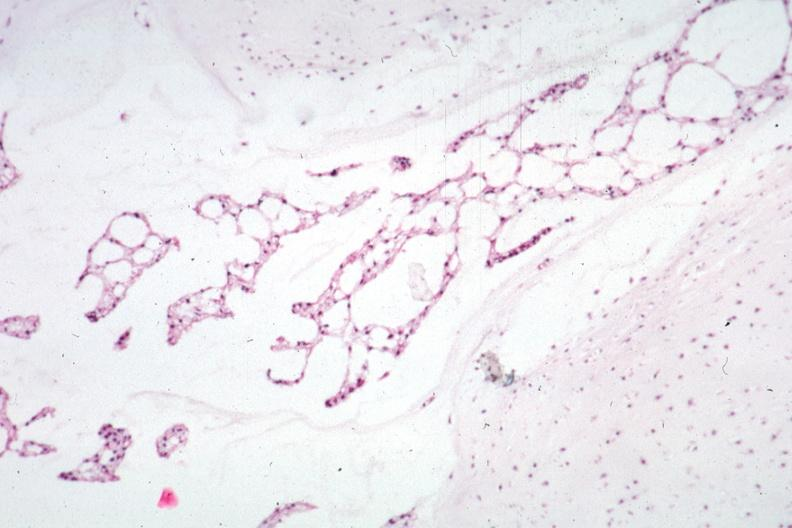what is present?
Answer the question using a single word or phrase. Notochord 